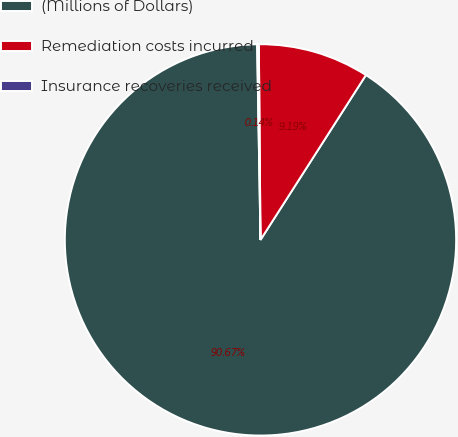Convert chart. <chart><loc_0><loc_0><loc_500><loc_500><pie_chart><fcel>(Millions of Dollars)<fcel>Remediation costs incurred<fcel>Insurance recoveries received<nl><fcel>90.67%<fcel>9.19%<fcel>0.14%<nl></chart> 